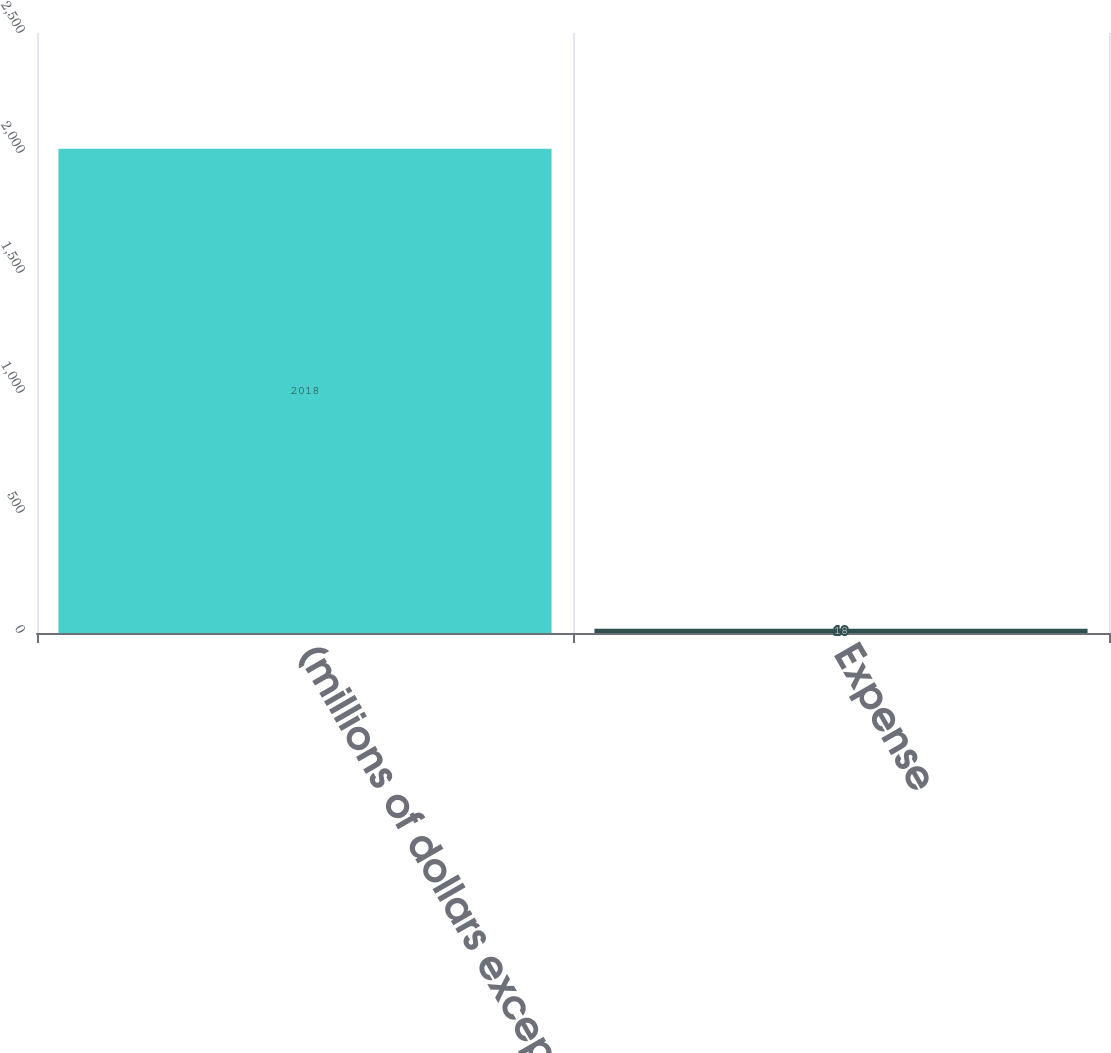Convert chart to OTSL. <chart><loc_0><loc_0><loc_500><loc_500><bar_chart><fcel>(millions of dollars except<fcel>Expense<nl><fcel>2018<fcel>18<nl></chart> 